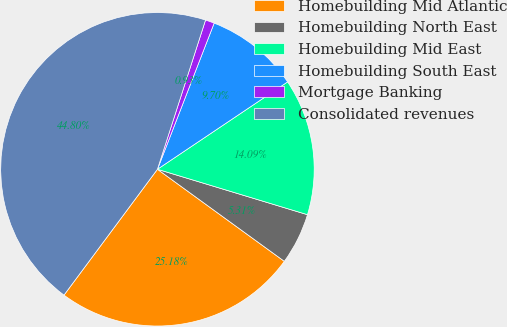Convert chart. <chart><loc_0><loc_0><loc_500><loc_500><pie_chart><fcel>Homebuilding Mid Atlantic<fcel>Homebuilding North East<fcel>Homebuilding Mid East<fcel>Homebuilding South East<fcel>Mortgage Banking<fcel>Consolidated revenues<nl><fcel>25.18%<fcel>5.31%<fcel>14.09%<fcel>9.7%<fcel>0.93%<fcel>44.8%<nl></chart> 